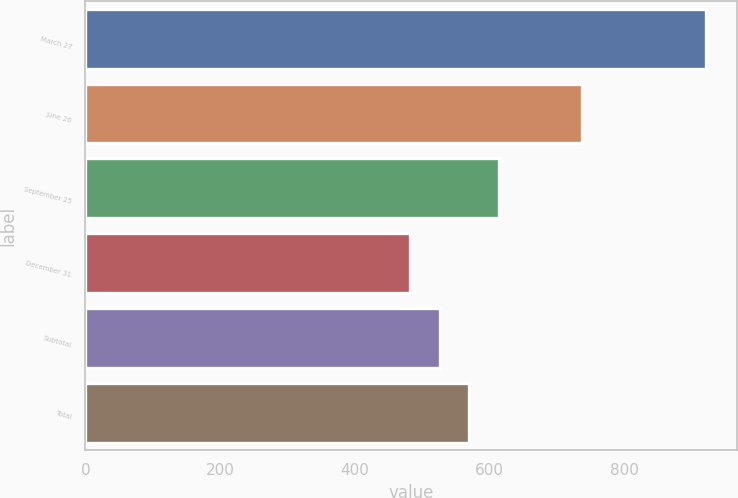<chart> <loc_0><loc_0><loc_500><loc_500><bar_chart><fcel>March 27<fcel>June 26<fcel>September 25<fcel>December 31<fcel>Subtotal<fcel>Total<nl><fcel>921<fcel>738<fcel>613.7<fcel>482<fcel>525.9<fcel>569.8<nl></chart> 